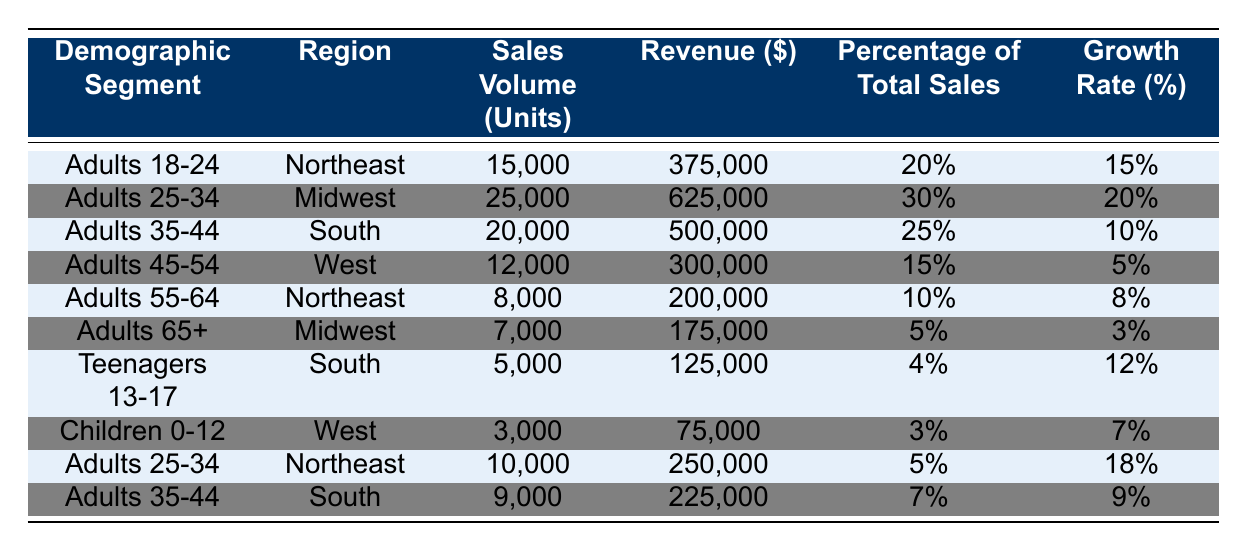What is the sales volume for Adults 25-34 in the Midwest? In the table, the sales volume of Adults 25-34 in the Midwest is listed directly under the "Sales Volume (Units)" column. It shows a value of 25,000 units.
Answer: 25,000 What is the total revenue generated by the Demographic Segment "Adults 18-24"? The revenue for Adults 18-24 is provided in the table, under the "Revenue ($)" column, which states that it is $375,000.
Answer: $375,000 Which demographic segment generated the highest percentage of total sales? By comparing the "Percentage of Total Sales" column, Adults 25-34 in the Midwest generated the highest at 30%.
Answer: Adults 25-34 (Midwest) How much revenue did Adults 65+ generate in total from both regions combined? The revenue for Adults 65+ is $175,000 in the Midwest. There is no data for another region in this demographic, so the total remains $175,000.
Answer: $175,000 What is the growth rate for Teenagers 13-17? The growth rate for Teenagers 13-17 is directly provided in the table under the "Growth Rate (%)" column, which shows a figure of 12%.
Answer: 12% What is the difference between the total sales volume for Adults 18-24 and Adults 45-54? Adults 18-24 have a sales volume of 15,000 units, and Adults 45-54 have 12,000 units. The difference is 15,000 - 12,000 = 3,000 units.
Answer: 3,000 What is the average growth rate for all demographic segments listed? To find the average growth rate, sum each growth rate (15 + 20 + 10 + 5 + 8 + 3 + 12 + 7 + 18 + 9 = 107) and then divide by the total number of segments (10). The average growth rate is 107 / 10 = 10.7%.
Answer: 10.7% Is the revenue from Adults 55-64 higher than from Children 0-12? The revenue for Adults 55-64 is $200,000, while for Children 0-12 it is $75,000. Since $200,000 is greater than $75,000, the statement is true.
Answer: Yes Which demographic segment has the lowest percentage of total sales? By examining the "Percentage of Total Sales" column, Children 0-12 show a percentage of 3%, which is the lowest compared to other segments.
Answer: Children 0-12 What demographic segment in the Northeast has the highest sales volume? In the Northeast, Adults 18-24 have a sales volume of 15,000 units, while Adults 55-64 have 8,000 units and Adults 25-34 have 10,000 units. Therefore, Adults 18-24 has the highest sales volume.
Answer: Adults 18-24 